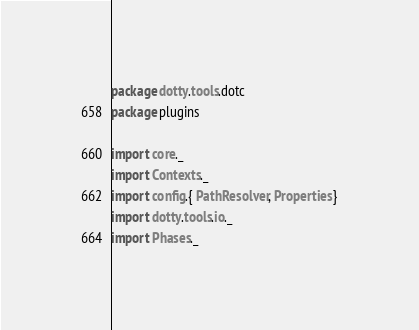<code> <loc_0><loc_0><loc_500><loc_500><_Scala_>package dotty.tools.dotc
package plugins

import core._
import Contexts._
import config.{ PathResolver, Properties }
import dotty.tools.io._
import Phases._</code> 